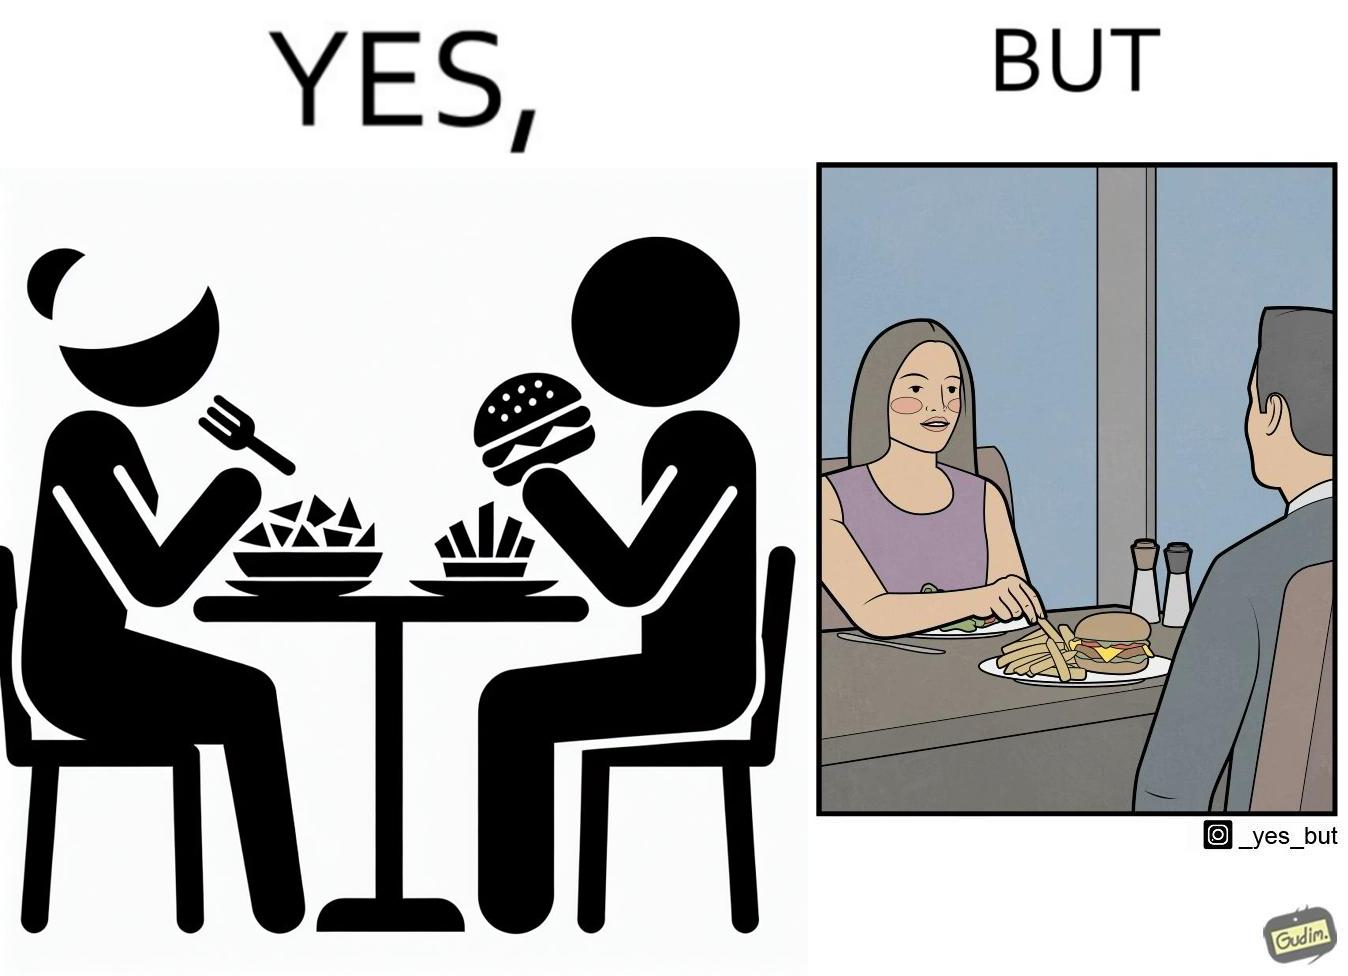What is shown in this image? The image is ironic because in the first image it is shown that the woman has got salad for her but she is having french fries from the man's plate which displays that the girl is trying to show herself as health conscious by having a plate of salad for her but she wants to have to have fast food but rather than having them for herself she is taking some from other's plate 